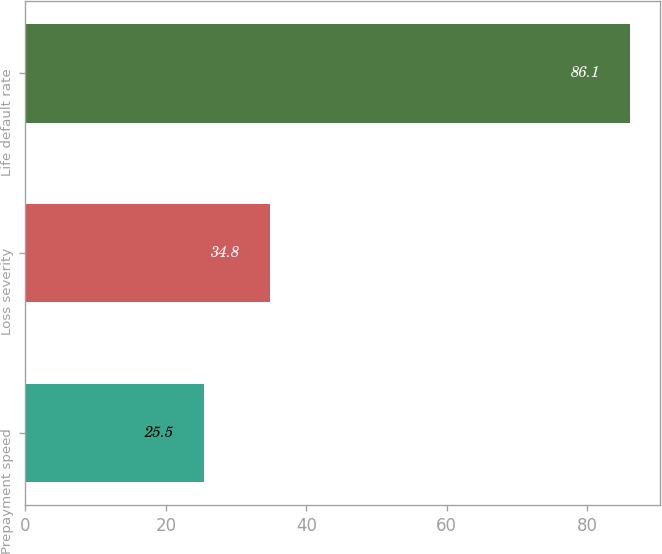Convert chart to OTSL. <chart><loc_0><loc_0><loc_500><loc_500><bar_chart><fcel>Prepayment speed<fcel>Loss severity<fcel>Life default rate<nl><fcel>25.5<fcel>34.8<fcel>86.1<nl></chart> 